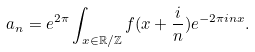Convert formula to latex. <formula><loc_0><loc_0><loc_500><loc_500>a _ { n } = e ^ { 2 \pi } \int _ { x \in \mathbb { R } / \mathbb { Z } } f ( x + \frac { i } { n } ) e ^ { - 2 \pi i n x } .</formula> 